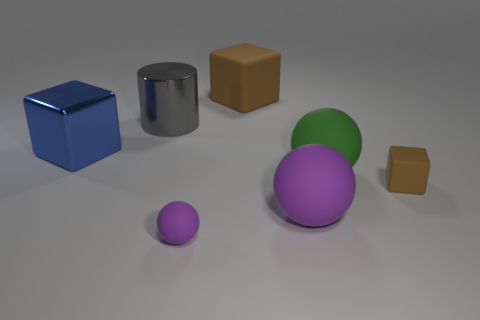Subtract all big purple rubber spheres. How many spheres are left? 2 Subtract all blue cubes. How many cubes are left? 2 Subtract all cylinders. How many objects are left? 6 Subtract 1 cylinders. How many cylinders are left? 0 Subtract all yellow cylinders. Subtract all blue spheres. How many cylinders are left? 1 Subtract all purple cylinders. How many blue blocks are left? 1 Subtract all brown blocks. Subtract all big gray cylinders. How many objects are left? 4 Add 3 metal blocks. How many metal blocks are left? 4 Add 6 gray things. How many gray things exist? 7 Add 1 blue cubes. How many objects exist? 8 